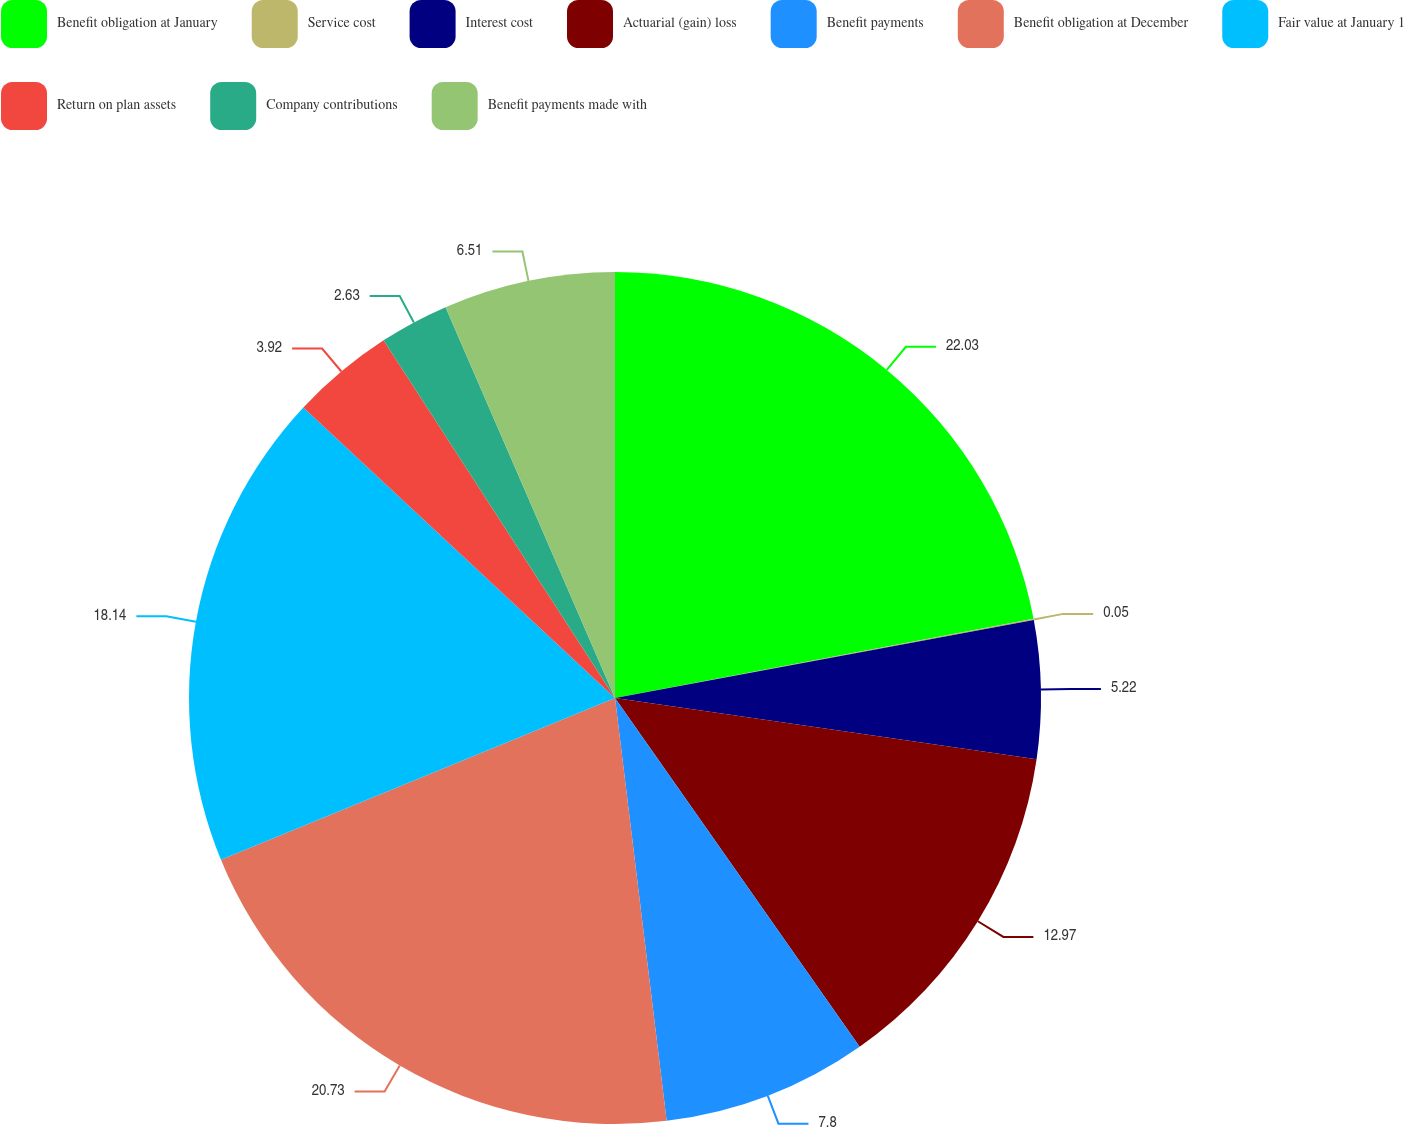Convert chart to OTSL. <chart><loc_0><loc_0><loc_500><loc_500><pie_chart><fcel>Benefit obligation at January<fcel>Service cost<fcel>Interest cost<fcel>Actuarial (gain) loss<fcel>Benefit payments<fcel>Benefit obligation at December<fcel>Fair value at January 1<fcel>Return on plan assets<fcel>Company contributions<fcel>Benefit payments made with<nl><fcel>22.02%<fcel>0.05%<fcel>5.22%<fcel>12.97%<fcel>7.8%<fcel>20.73%<fcel>18.14%<fcel>3.92%<fcel>2.63%<fcel>6.51%<nl></chart> 